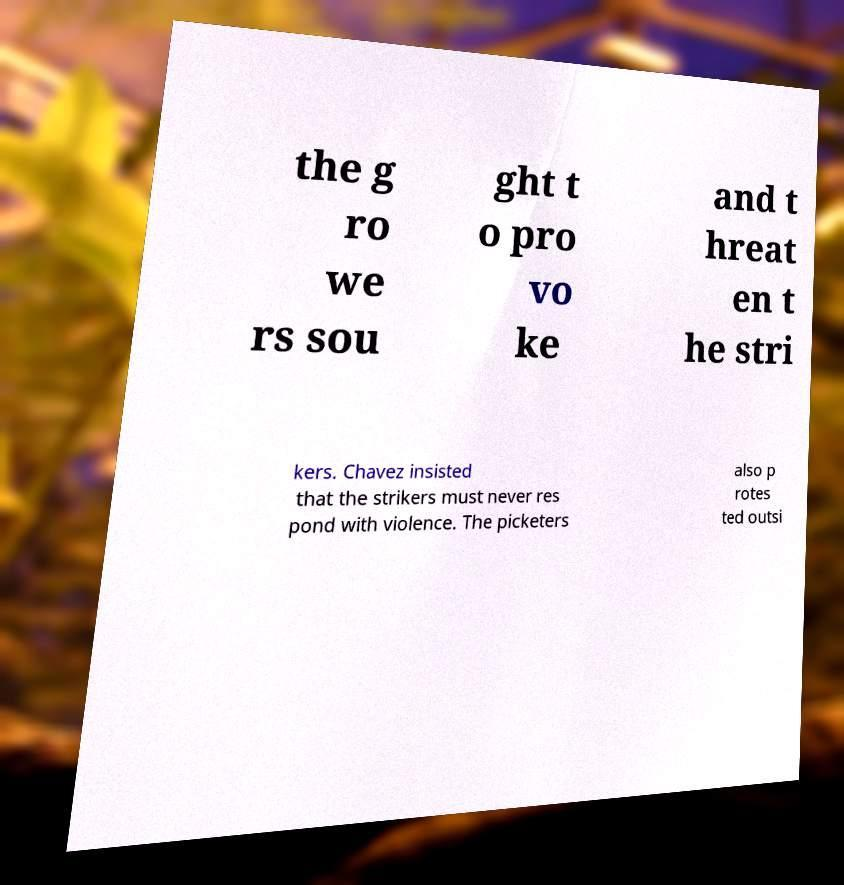Can you accurately transcribe the text from the provided image for me? the g ro we rs sou ght t o pro vo ke and t hreat en t he stri kers. Chavez insisted that the strikers must never res pond with violence. The picketers also p rotes ted outsi 